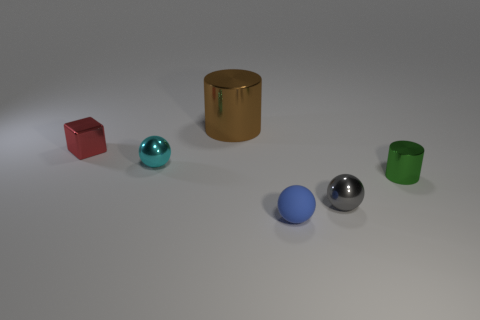Does the cyan object have the same material as the small blue thing?
Offer a terse response. No. Is there any other thing that is made of the same material as the small blue thing?
Provide a succinct answer. No. Is there anything else that is the same size as the brown shiny cylinder?
Your answer should be very brief. No. There is a shiny thing that is right of the tiny cyan shiny thing and on the left side of the small gray metallic sphere; what is its size?
Provide a succinct answer. Large. There is a tiny cyan thing that is the same material as the small gray ball; what is its shape?
Offer a terse response. Sphere. Is the material of the cube the same as the cylinder that is to the right of the tiny gray metallic object?
Provide a short and direct response. Yes. There is a thing on the right side of the gray sphere; are there any large brown things right of it?
Make the answer very short. No. There is a small blue object that is the same shape as the tiny cyan metallic object; what is it made of?
Your answer should be very brief. Rubber. There is a tiny shiny ball that is right of the blue object; how many blue matte balls are in front of it?
Your response must be concise. 1. Is there any other thing of the same color as the tiny matte thing?
Provide a short and direct response. No. 